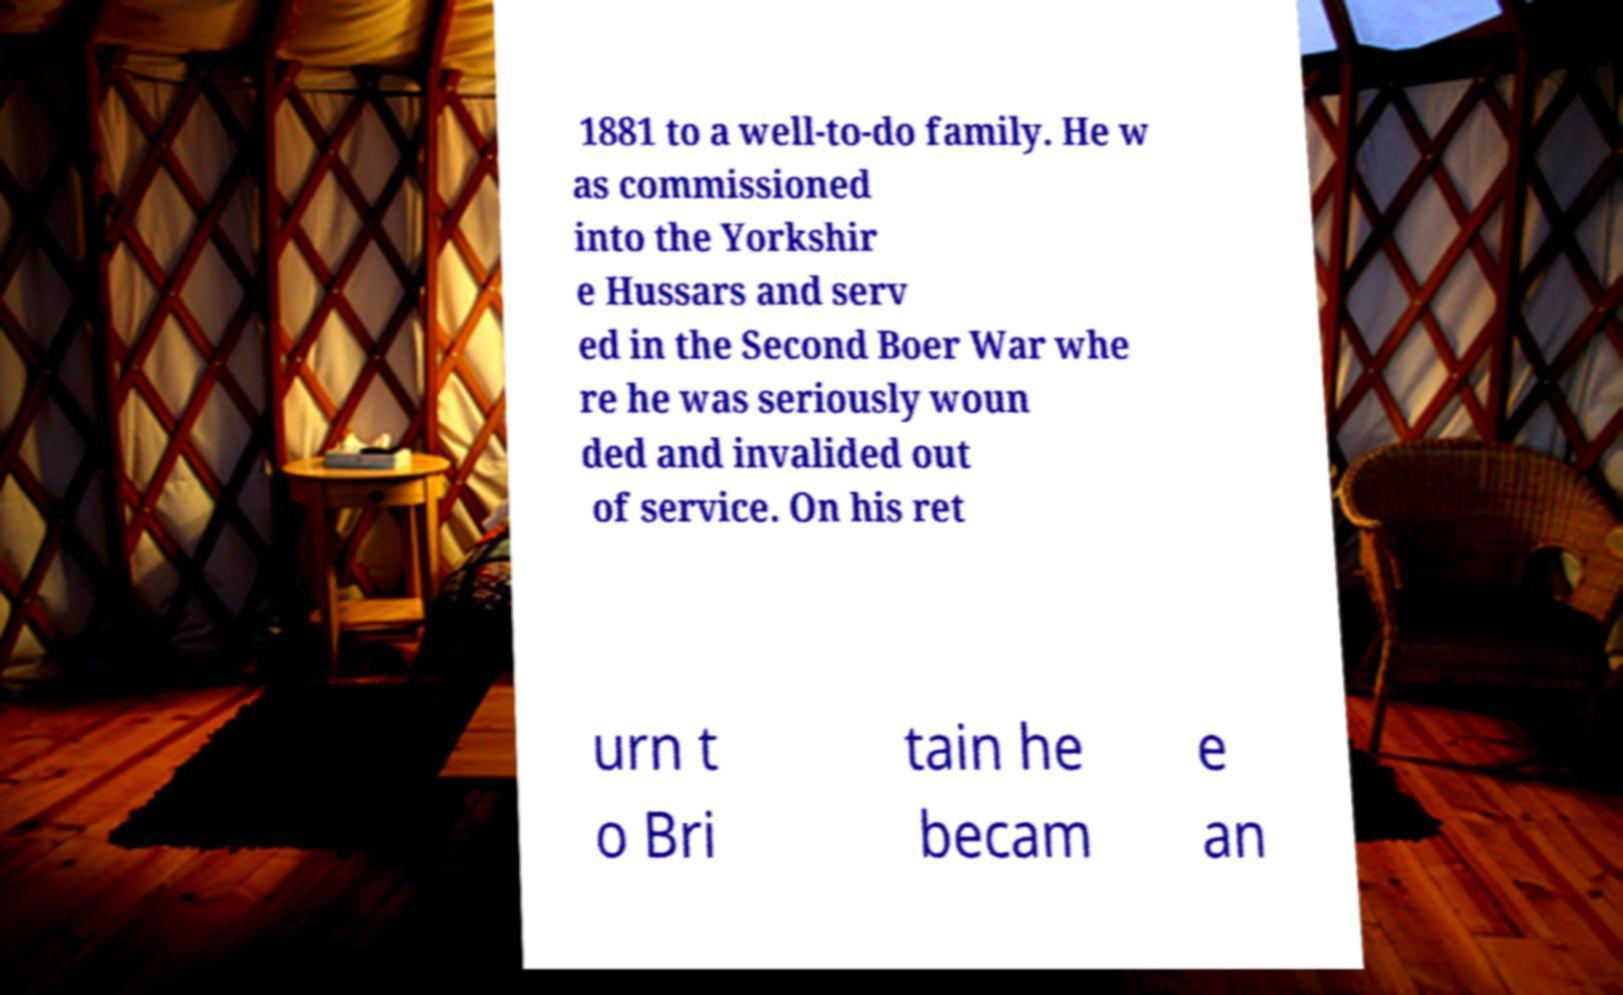Could you extract and type out the text from this image? 1881 to a well-to-do family. He w as commissioned into the Yorkshir e Hussars and serv ed in the Second Boer War whe re he was seriously woun ded and invalided out of service. On his ret urn t o Bri tain he becam e an 